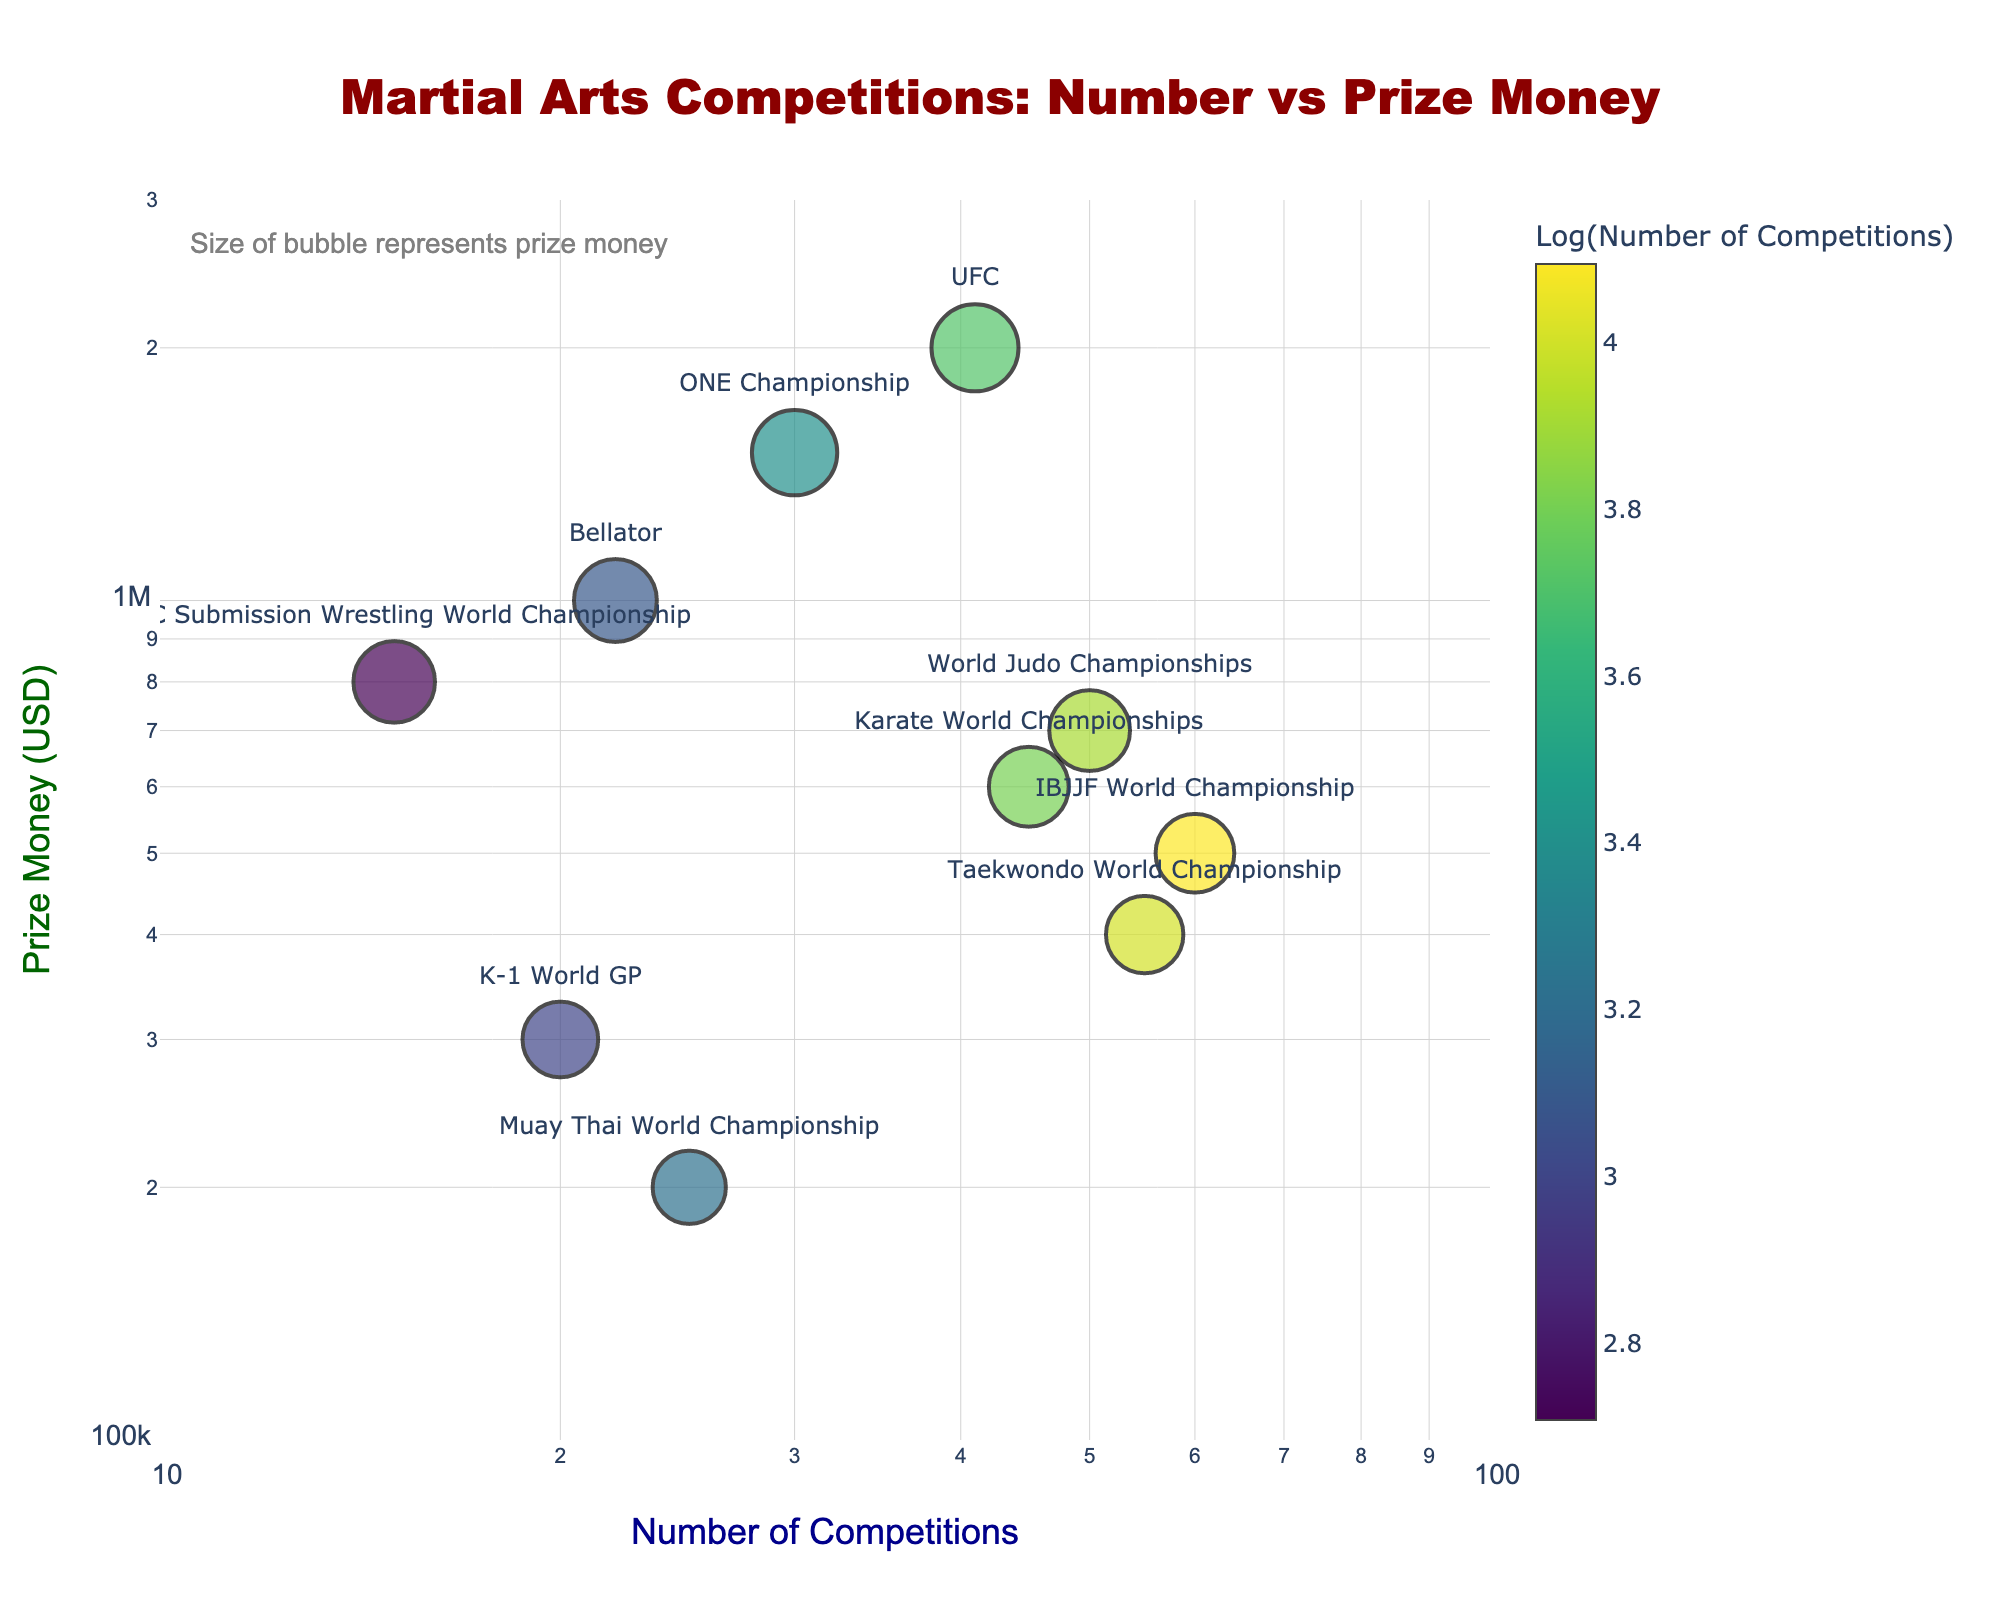What is the title of the figure? The title of the figure is usually placed at the top and is the most prominent text. It provides a quick overview of what the plot represents.
Answer: Martial Arts Competitions: Number vs Prize Money How many data points are there in the figure? Count the number of unique markers (bubbles) on the scatter plot. Each marker represents a data point from the dataset.
Answer: 10 Which martial art competition has the highest prize money? Look for the highest value on the y-axis (Prize Money) and identify the corresponding label (text) near the data point.
Answer: UFC What is the prize money for the Taekwondo World Championship? Locate the label "Taekwondo World Championship" on the plot and read the y-axis value corresponding to this label.
Answer: $400,000 Which competition has the smallest number of competitions held annually? Look for the lowest value on the x-axis (Number of Competitions) and identify the corresponding label.
Answer: ADCC Submission Wrestling World Championship Which competition has a higher prize money: Bellator or Muay Thai World Championship? Compare the y-axis values corresponding to the labels "Bellator" and "Muay Thai World Championship."
Answer: Bellator What is the general trend between the number of competitions and prize money distribution? Observe the overall pattern of the data points in the plot. Determine if there is an increasing or decreasing trend or if it's scattered randomly.
Answer: No clear trend If you take the logarithm of the prize money for UFC, what is the approximate value? You need to approximate the logarithm of the UFC prize money ($2,000,000) using base 10 logarithm.
Answer: Approximately 6.3 Which competition has a larger bubble size: ONE Championship or K-1 World GP? Bubble size represents the prize money. Compare the bubble sizes visually for "ONE Championship" and "K-1 World GP."
Answer: ONE Championship What can you infer about the relationship between competition frequency and prize money from the plot? Analyze if there’s a discernible pattern showing that more frequent competitions correlate with higher or lower prize money, or if there's no clear relationship.
Answer: No clear relationship 